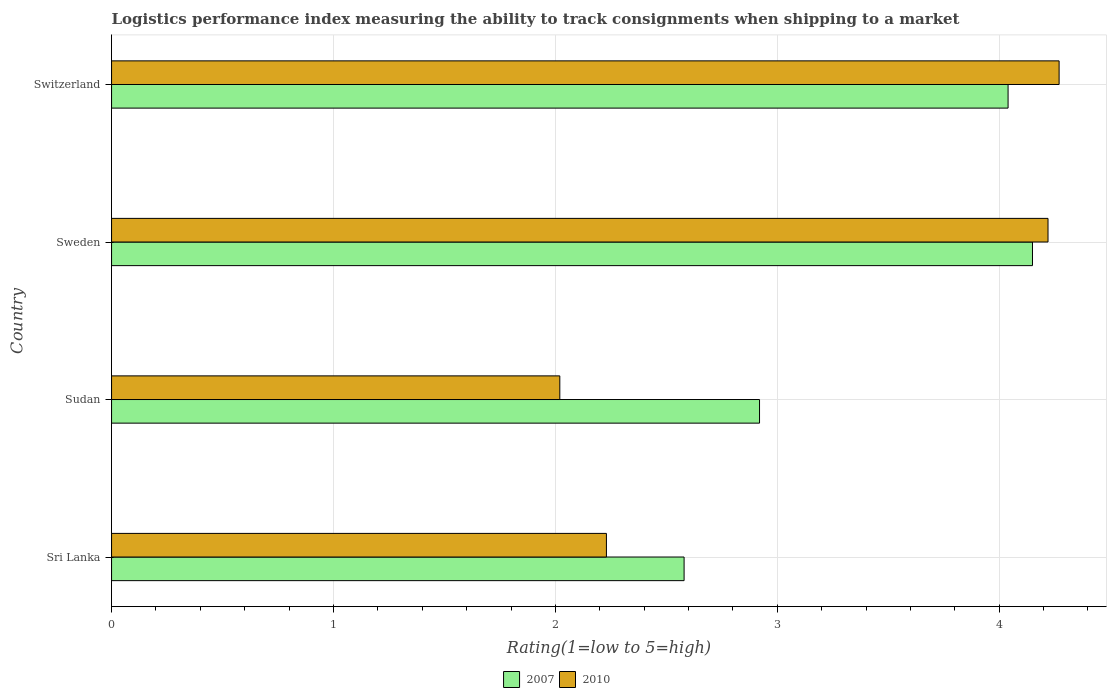How many different coloured bars are there?
Provide a short and direct response. 2. How many groups of bars are there?
Give a very brief answer. 4. Are the number of bars per tick equal to the number of legend labels?
Give a very brief answer. Yes. Are the number of bars on each tick of the Y-axis equal?
Provide a succinct answer. Yes. What is the label of the 4th group of bars from the top?
Your answer should be compact. Sri Lanka. In how many cases, is the number of bars for a given country not equal to the number of legend labels?
Offer a very short reply. 0. What is the Logistic performance index in 2010 in Sweden?
Provide a short and direct response. 4.22. Across all countries, what is the maximum Logistic performance index in 2007?
Your answer should be compact. 4.15. Across all countries, what is the minimum Logistic performance index in 2010?
Your answer should be compact. 2.02. In which country was the Logistic performance index in 2010 maximum?
Offer a terse response. Switzerland. In which country was the Logistic performance index in 2010 minimum?
Ensure brevity in your answer.  Sudan. What is the total Logistic performance index in 2010 in the graph?
Provide a succinct answer. 12.74. What is the difference between the Logistic performance index in 2010 in Sudan and that in Switzerland?
Keep it short and to the point. -2.25. What is the difference between the Logistic performance index in 2007 in Switzerland and the Logistic performance index in 2010 in Sweden?
Make the answer very short. -0.18. What is the average Logistic performance index in 2007 per country?
Ensure brevity in your answer.  3.42. What is the difference between the Logistic performance index in 2010 and Logistic performance index in 2007 in Switzerland?
Your answer should be compact. 0.23. What is the ratio of the Logistic performance index in 2007 in Sri Lanka to that in Sudan?
Offer a terse response. 0.88. Is the Logistic performance index in 2010 in Sri Lanka less than that in Sweden?
Make the answer very short. Yes. What is the difference between the highest and the second highest Logistic performance index in 2010?
Your response must be concise. 0.05. What is the difference between the highest and the lowest Logistic performance index in 2010?
Make the answer very short. 2.25. In how many countries, is the Logistic performance index in 2010 greater than the average Logistic performance index in 2010 taken over all countries?
Offer a very short reply. 2. What does the 2nd bar from the top in Sudan represents?
Offer a very short reply. 2007. What does the 2nd bar from the bottom in Sri Lanka represents?
Offer a terse response. 2010. How many bars are there?
Your answer should be compact. 8. Are all the bars in the graph horizontal?
Keep it short and to the point. Yes. What is the difference between two consecutive major ticks on the X-axis?
Provide a succinct answer. 1. Does the graph contain any zero values?
Your answer should be compact. No. How many legend labels are there?
Offer a very short reply. 2. What is the title of the graph?
Your response must be concise. Logistics performance index measuring the ability to track consignments when shipping to a market. Does "1961" appear as one of the legend labels in the graph?
Ensure brevity in your answer.  No. What is the label or title of the X-axis?
Give a very brief answer. Rating(1=low to 5=high). What is the Rating(1=low to 5=high) in 2007 in Sri Lanka?
Provide a succinct answer. 2.58. What is the Rating(1=low to 5=high) in 2010 in Sri Lanka?
Your answer should be very brief. 2.23. What is the Rating(1=low to 5=high) in 2007 in Sudan?
Ensure brevity in your answer.  2.92. What is the Rating(1=low to 5=high) in 2010 in Sudan?
Your response must be concise. 2.02. What is the Rating(1=low to 5=high) of 2007 in Sweden?
Provide a succinct answer. 4.15. What is the Rating(1=low to 5=high) of 2010 in Sweden?
Make the answer very short. 4.22. What is the Rating(1=low to 5=high) of 2007 in Switzerland?
Your response must be concise. 4.04. What is the Rating(1=low to 5=high) of 2010 in Switzerland?
Keep it short and to the point. 4.27. Across all countries, what is the maximum Rating(1=low to 5=high) of 2007?
Your answer should be very brief. 4.15. Across all countries, what is the maximum Rating(1=low to 5=high) of 2010?
Provide a succinct answer. 4.27. Across all countries, what is the minimum Rating(1=low to 5=high) in 2007?
Keep it short and to the point. 2.58. Across all countries, what is the minimum Rating(1=low to 5=high) of 2010?
Give a very brief answer. 2.02. What is the total Rating(1=low to 5=high) of 2007 in the graph?
Give a very brief answer. 13.69. What is the total Rating(1=low to 5=high) of 2010 in the graph?
Your response must be concise. 12.74. What is the difference between the Rating(1=low to 5=high) in 2007 in Sri Lanka and that in Sudan?
Ensure brevity in your answer.  -0.34. What is the difference between the Rating(1=low to 5=high) of 2010 in Sri Lanka and that in Sudan?
Keep it short and to the point. 0.21. What is the difference between the Rating(1=low to 5=high) in 2007 in Sri Lanka and that in Sweden?
Your answer should be very brief. -1.57. What is the difference between the Rating(1=low to 5=high) in 2010 in Sri Lanka and that in Sweden?
Give a very brief answer. -1.99. What is the difference between the Rating(1=low to 5=high) in 2007 in Sri Lanka and that in Switzerland?
Your response must be concise. -1.46. What is the difference between the Rating(1=low to 5=high) of 2010 in Sri Lanka and that in Switzerland?
Offer a terse response. -2.04. What is the difference between the Rating(1=low to 5=high) in 2007 in Sudan and that in Sweden?
Keep it short and to the point. -1.23. What is the difference between the Rating(1=low to 5=high) of 2007 in Sudan and that in Switzerland?
Your answer should be compact. -1.12. What is the difference between the Rating(1=low to 5=high) in 2010 in Sudan and that in Switzerland?
Provide a short and direct response. -2.25. What is the difference between the Rating(1=low to 5=high) in 2007 in Sweden and that in Switzerland?
Provide a short and direct response. 0.11. What is the difference between the Rating(1=low to 5=high) of 2010 in Sweden and that in Switzerland?
Your response must be concise. -0.05. What is the difference between the Rating(1=low to 5=high) in 2007 in Sri Lanka and the Rating(1=low to 5=high) in 2010 in Sudan?
Ensure brevity in your answer.  0.56. What is the difference between the Rating(1=low to 5=high) of 2007 in Sri Lanka and the Rating(1=low to 5=high) of 2010 in Sweden?
Your answer should be very brief. -1.64. What is the difference between the Rating(1=low to 5=high) of 2007 in Sri Lanka and the Rating(1=low to 5=high) of 2010 in Switzerland?
Your answer should be very brief. -1.69. What is the difference between the Rating(1=low to 5=high) of 2007 in Sudan and the Rating(1=low to 5=high) of 2010 in Switzerland?
Ensure brevity in your answer.  -1.35. What is the difference between the Rating(1=low to 5=high) in 2007 in Sweden and the Rating(1=low to 5=high) in 2010 in Switzerland?
Your answer should be compact. -0.12. What is the average Rating(1=low to 5=high) of 2007 per country?
Keep it short and to the point. 3.42. What is the average Rating(1=low to 5=high) in 2010 per country?
Provide a short and direct response. 3.19. What is the difference between the Rating(1=low to 5=high) in 2007 and Rating(1=low to 5=high) in 2010 in Sri Lanka?
Make the answer very short. 0.35. What is the difference between the Rating(1=low to 5=high) in 2007 and Rating(1=low to 5=high) in 2010 in Sudan?
Keep it short and to the point. 0.9. What is the difference between the Rating(1=low to 5=high) in 2007 and Rating(1=low to 5=high) in 2010 in Sweden?
Provide a succinct answer. -0.07. What is the difference between the Rating(1=low to 5=high) of 2007 and Rating(1=low to 5=high) of 2010 in Switzerland?
Provide a short and direct response. -0.23. What is the ratio of the Rating(1=low to 5=high) in 2007 in Sri Lanka to that in Sudan?
Your answer should be very brief. 0.88. What is the ratio of the Rating(1=low to 5=high) of 2010 in Sri Lanka to that in Sudan?
Keep it short and to the point. 1.1. What is the ratio of the Rating(1=low to 5=high) of 2007 in Sri Lanka to that in Sweden?
Your answer should be very brief. 0.62. What is the ratio of the Rating(1=low to 5=high) in 2010 in Sri Lanka to that in Sweden?
Provide a short and direct response. 0.53. What is the ratio of the Rating(1=low to 5=high) in 2007 in Sri Lanka to that in Switzerland?
Make the answer very short. 0.64. What is the ratio of the Rating(1=low to 5=high) of 2010 in Sri Lanka to that in Switzerland?
Provide a succinct answer. 0.52. What is the ratio of the Rating(1=low to 5=high) of 2007 in Sudan to that in Sweden?
Ensure brevity in your answer.  0.7. What is the ratio of the Rating(1=low to 5=high) in 2010 in Sudan to that in Sweden?
Your response must be concise. 0.48. What is the ratio of the Rating(1=low to 5=high) of 2007 in Sudan to that in Switzerland?
Keep it short and to the point. 0.72. What is the ratio of the Rating(1=low to 5=high) in 2010 in Sudan to that in Switzerland?
Make the answer very short. 0.47. What is the ratio of the Rating(1=low to 5=high) of 2007 in Sweden to that in Switzerland?
Ensure brevity in your answer.  1.03. What is the ratio of the Rating(1=low to 5=high) of 2010 in Sweden to that in Switzerland?
Your response must be concise. 0.99. What is the difference between the highest and the second highest Rating(1=low to 5=high) in 2007?
Offer a terse response. 0.11. What is the difference between the highest and the lowest Rating(1=low to 5=high) in 2007?
Ensure brevity in your answer.  1.57. What is the difference between the highest and the lowest Rating(1=low to 5=high) of 2010?
Provide a succinct answer. 2.25. 